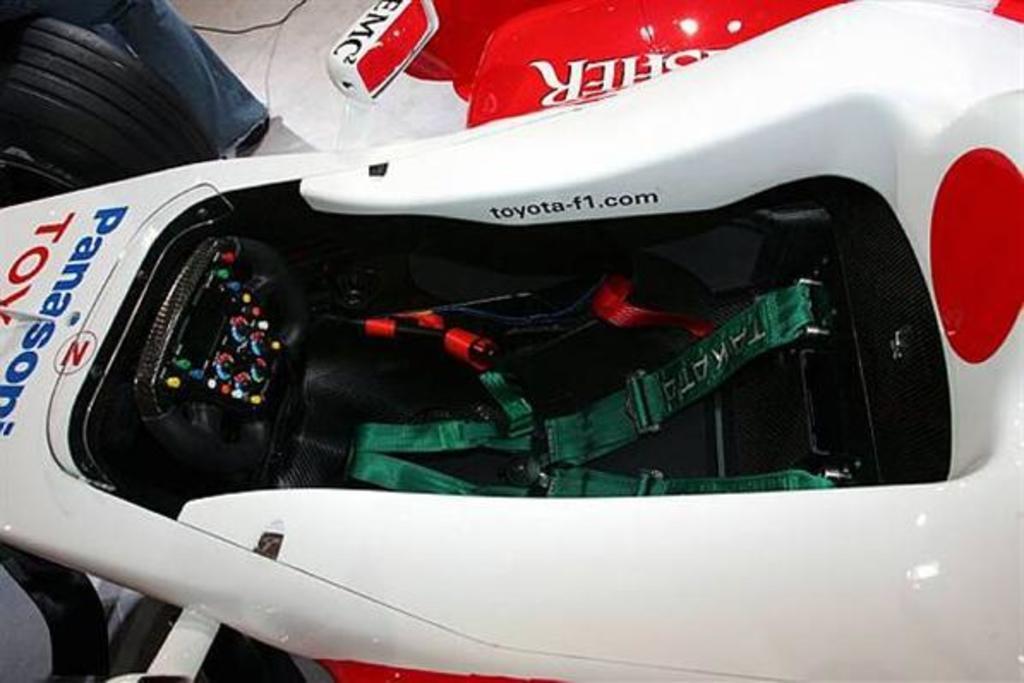Can you describe this image briefly? In this picture we can see a vehicle, cable, person's leg on the floor and some objects. 